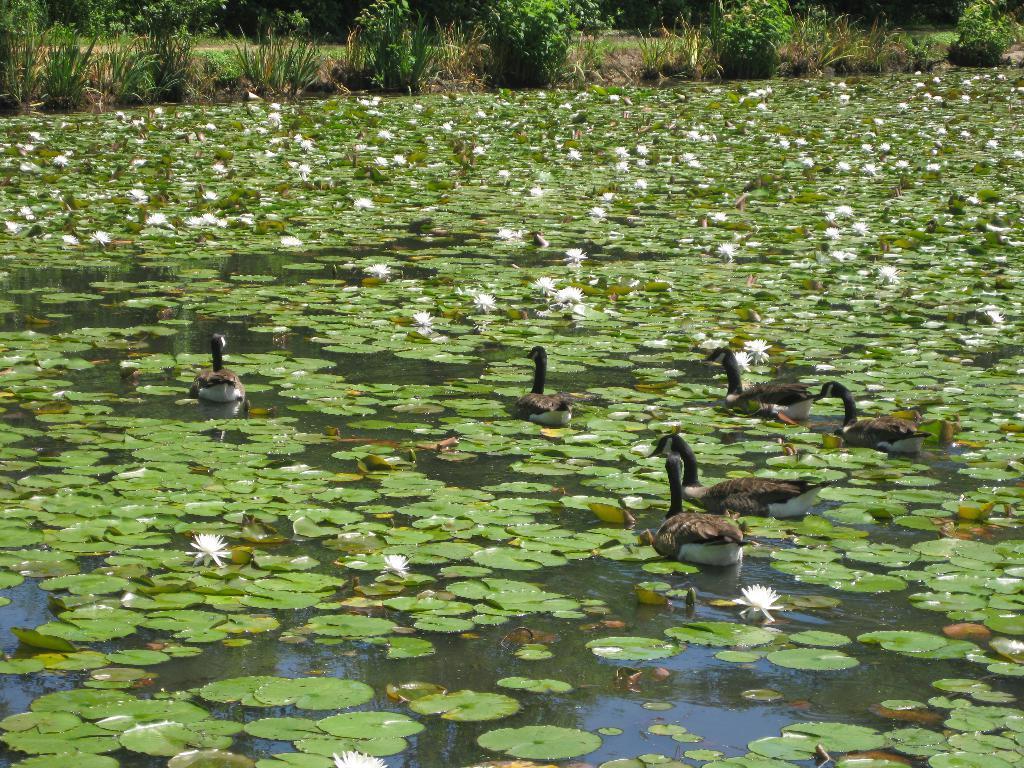In one or two sentences, can you explain what this image depicts? In this picture I can see flowers and leaves and few ducks in the water and I can see plants on the side. 